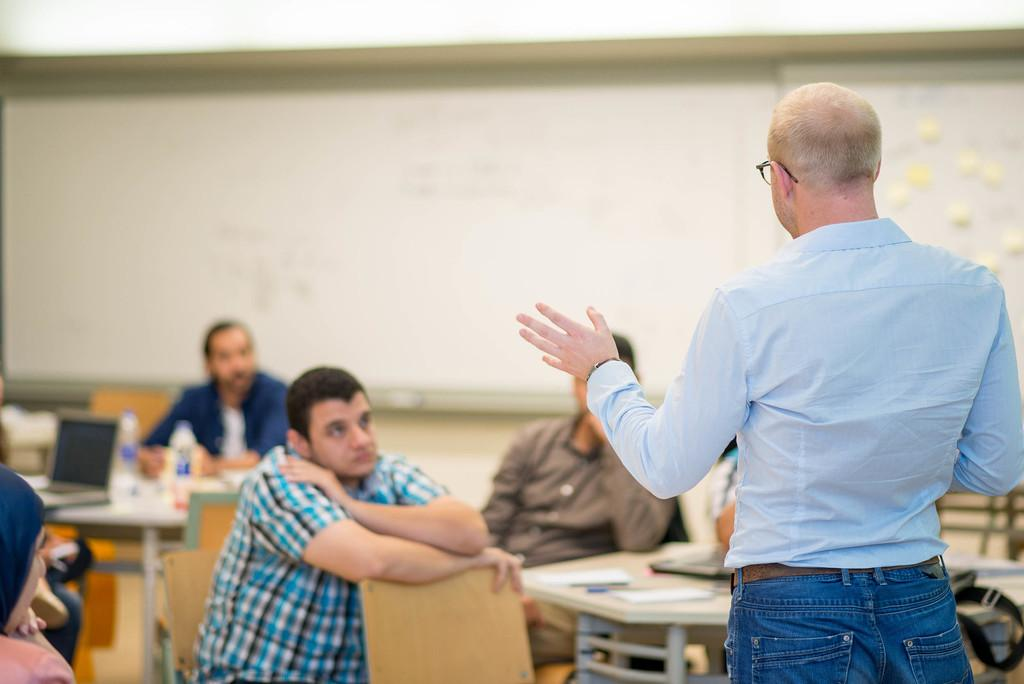What type of setting is shown in the image? The image depicts a classroom. What are the students doing in the classroom? The students are sitting on chairs in the classroom. What is the teacher doing in the classroom? A person is standing and teaching in the classroom. Can you describe any specific features of the classroom? There is a white color pole in the background of the classroom. What type of orange is being used as a prop in the classroom? There is no orange present in the image; it is a classroom setting with students and a teacher. 